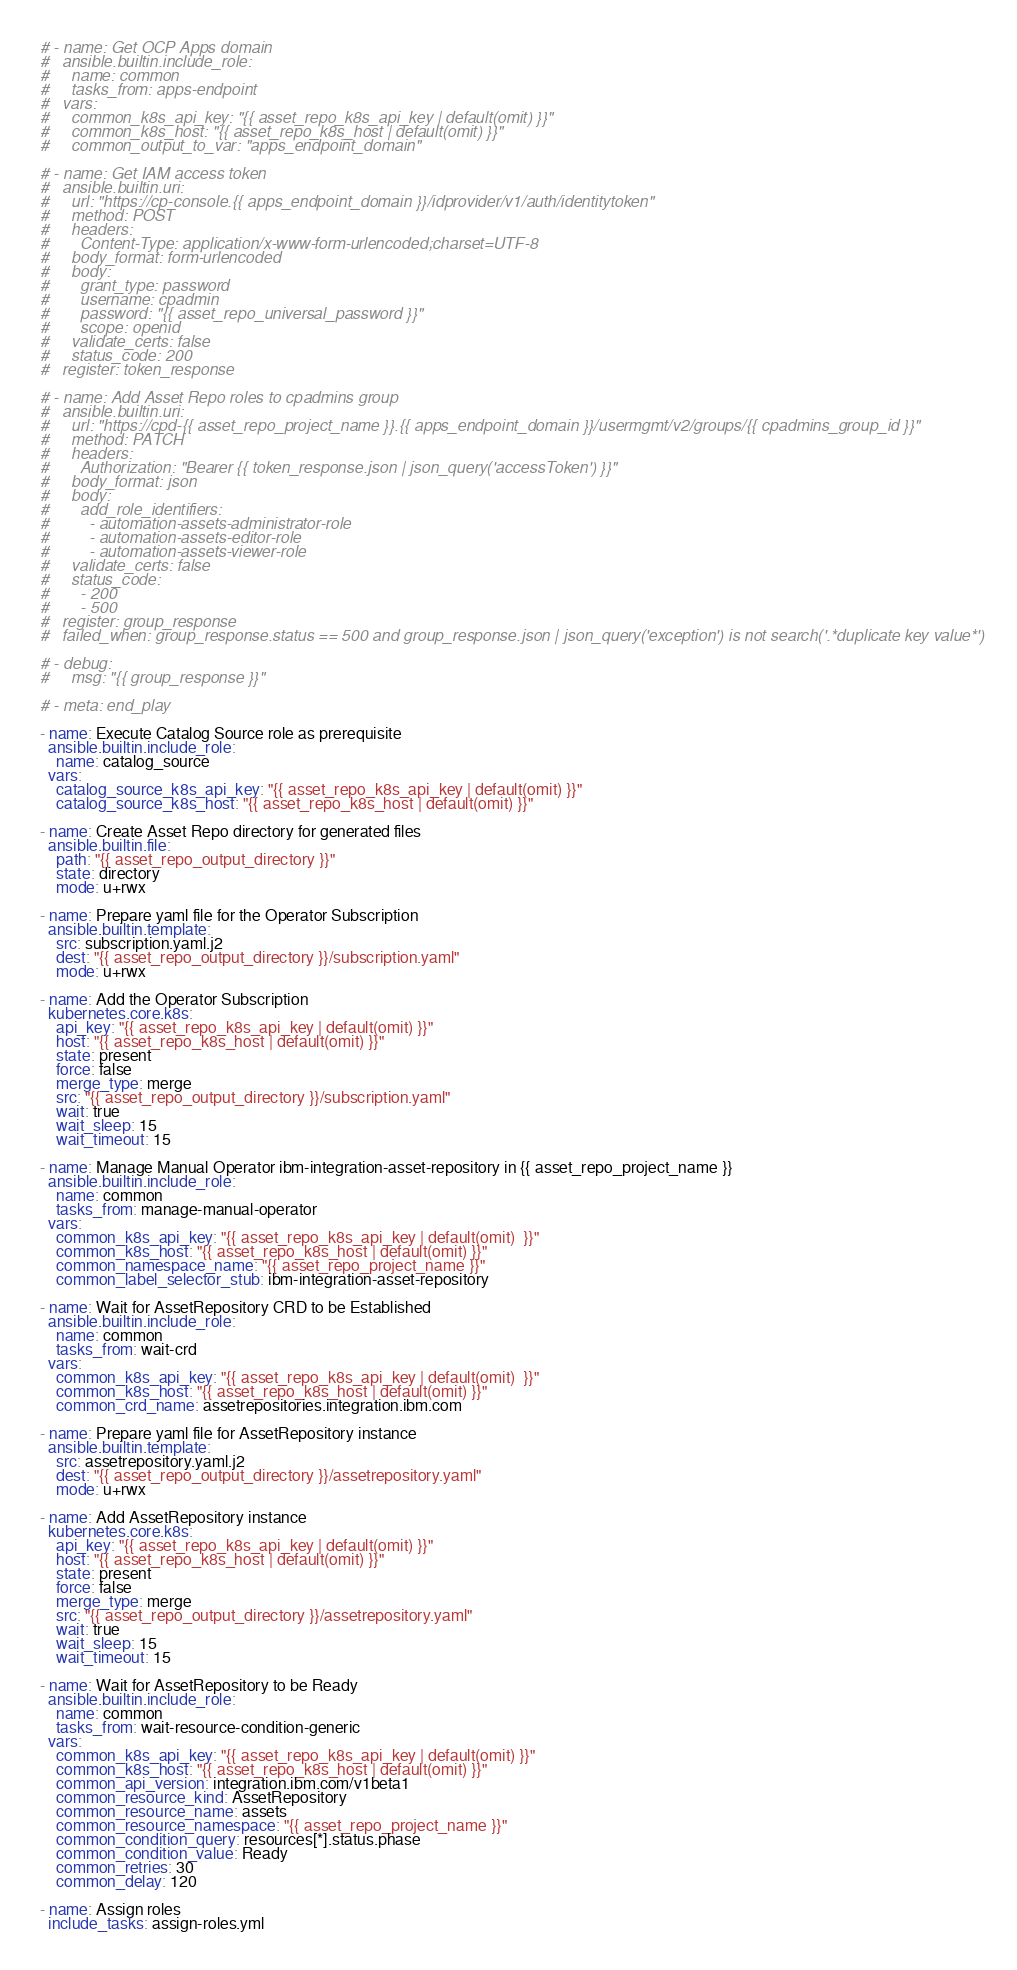Convert code to text. <code><loc_0><loc_0><loc_500><loc_500><_YAML_># - name: Get OCP Apps domain
#   ansible.builtin.include_role:
#     name: common
#     tasks_from: apps-endpoint
#   vars:
#     common_k8s_api_key: "{{ asset_repo_k8s_api_key | default(omit) }}"
#     common_k8s_host: "{{ asset_repo_k8s_host | default(omit) }}"
#     common_output_to_var: "apps_endpoint_domain"

# - name: Get IAM access token
#   ansible.builtin.uri:
#     url: "https://cp-console.{{ apps_endpoint_domain }}/idprovider/v1/auth/identitytoken"
#     method: POST
#     headers:
#       Content-Type: application/x-www-form-urlencoded;charset=UTF-8
#     body_format: form-urlencoded
#     body:
#       grant_type: password
#       username: cpadmin
#       password: "{{ asset_repo_universal_password }}"
#       scope: openid
#     validate_certs: false
#     status_code: 200
#   register: token_response

# - name: Add Asset Repo roles to cpadmins group
#   ansible.builtin.uri:
#     url: "https://cpd-{{ asset_repo_project_name }}.{{ apps_endpoint_domain }}/usermgmt/v2/groups/{{ cpadmins_group_id }}"
#     method: PATCH
#     headers:
#       Authorization: "Bearer {{ token_response.json | json_query('accessToken') }}"
#     body_format: json
#     body:
#       add_role_identifiers:
#         - automation-assets-administrator-role
#         - automation-assets-editor-role
#         - automation-assets-viewer-role
#     validate_certs: false
#     status_code:
#       - 200
#       - 500
#   register: group_response
#   failed_when: group_response.status == 500 and group_response.json | json_query('exception') is not search('.*duplicate key value*')

# - debug:
#     msg: "{{ group_response }}"

# - meta: end_play

- name: Execute Catalog Source role as prerequisite
  ansible.builtin.include_role:
    name: catalog_source
  vars:
    catalog_source_k8s_api_key: "{{ asset_repo_k8s_api_key | default(omit) }}"
    catalog_source_k8s_host: "{{ asset_repo_k8s_host | default(omit) }}"

- name: Create Asset Repo directory for generated files
  ansible.builtin.file:
    path: "{{ asset_repo_output_directory }}"
    state: directory
    mode: u+rwx

- name: Prepare yaml file for the Operator Subscription
  ansible.builtin.template:
    src: subscription.yaml.j2
    dest: "{{ asset_repo_output_directory }}/subscription.yaml"
    mode: u+rwx

- name: Add the Operator Subscription
  kubernetes.core.k8s:
    api_key: "{{ asset_repo_k8s_api_key | default(omit) }}"
    host: "{{ asset_repo_k8s_host | default(omit) }}"
    state: present
    force: false
    merge_type: merge
    src: "{{ asset_repo_output_directory }}/subscription.yaml"
    wait: true
    wait_sleep: 15
    wait_timeout: 15

- name: Manage Manual Operator ibm-integration-asset-repository in {{ asset_repo_project_name }}
  ansible.builtin.include_role:
    name: common
    tasks_from: manage-manual-operator
  vars:
    common_k8s_api_key: "{{ asset_repo_k8s_api_key | default(omit)  }}"
    common_k8s_host: "{{ asset_repo_k8s_host | default(omit) }}"
    common_namespace_name: "{{ asset_repo_project_name }}"
    common_label_selector_stub: ibm-integration-asset-repository

- name: Wait for AssetRepository CRD to be Established
  ansible.builtin.include_role:
    name: common
    tasks_from: wait-crd
  vars:
    common_k8s_api_key: "{{ asset_repo_k8s_api_key | default(omit)  }}"
    common_k8s_host: "{{ asset_repo_k8s_host | default(omit) }}"
    common_crd_name: assetrepositories.integration.ibm.com

- name: Prepare yaml file for AssetRepository instance
  ansible.builtin.template:
    src: assetrepository.yaml.j2
    dest: "{{ asset_repo_output_directory }}/assetrepository.yaml"
    mode: u+rwx

- name: Add AssetRepository instance
  kubernetes.core.k8s:
    api_key: "{{ asset_repo_k8s_api_key | default(omit) }}"
    host: "{{ asset_repo_k8s_host | default(omit) }}"
    state: present
    force: false
    merge_type: merge
    src: "{{ asset_repo_output_directory }}/assetrepository.yaml"
    wait: true
    wait_sleep: 15
    wait_timeout: 15

- name: Wait for AssetRepository to be Ready
  ansible.builtin.include_role:
    name: common
    tasks_from: wait-resource-condition-generic
  vars:
    common_k8s_api_key: "{{ asset_repo_k8s_api_key | default(omit) }}"
    common_k8s_host: "{{ asset_repo_k8s_host | default(omit) }}"
    common_api_version: integration.ibm.com/v1beta1
    common_resource_kind: AssetRepository
    common_resource_name: assets
    common_resource_namespace: "{{ asset_repo_project_name }}"
    common_condition_query: resources[*].status.phase
    common_condition_value: Ready
    common_retries: 30
    common_delay: 120

- name: Assign roles
  include_tasks: assign-roles.yml
</code> 